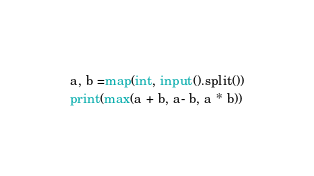Convert code to text. <code><loc_0><loc_0><loc_500><loc_500><_Python_>a, b =map(int, input().split())
print(max(a + b, a- b, a * b))</code> 